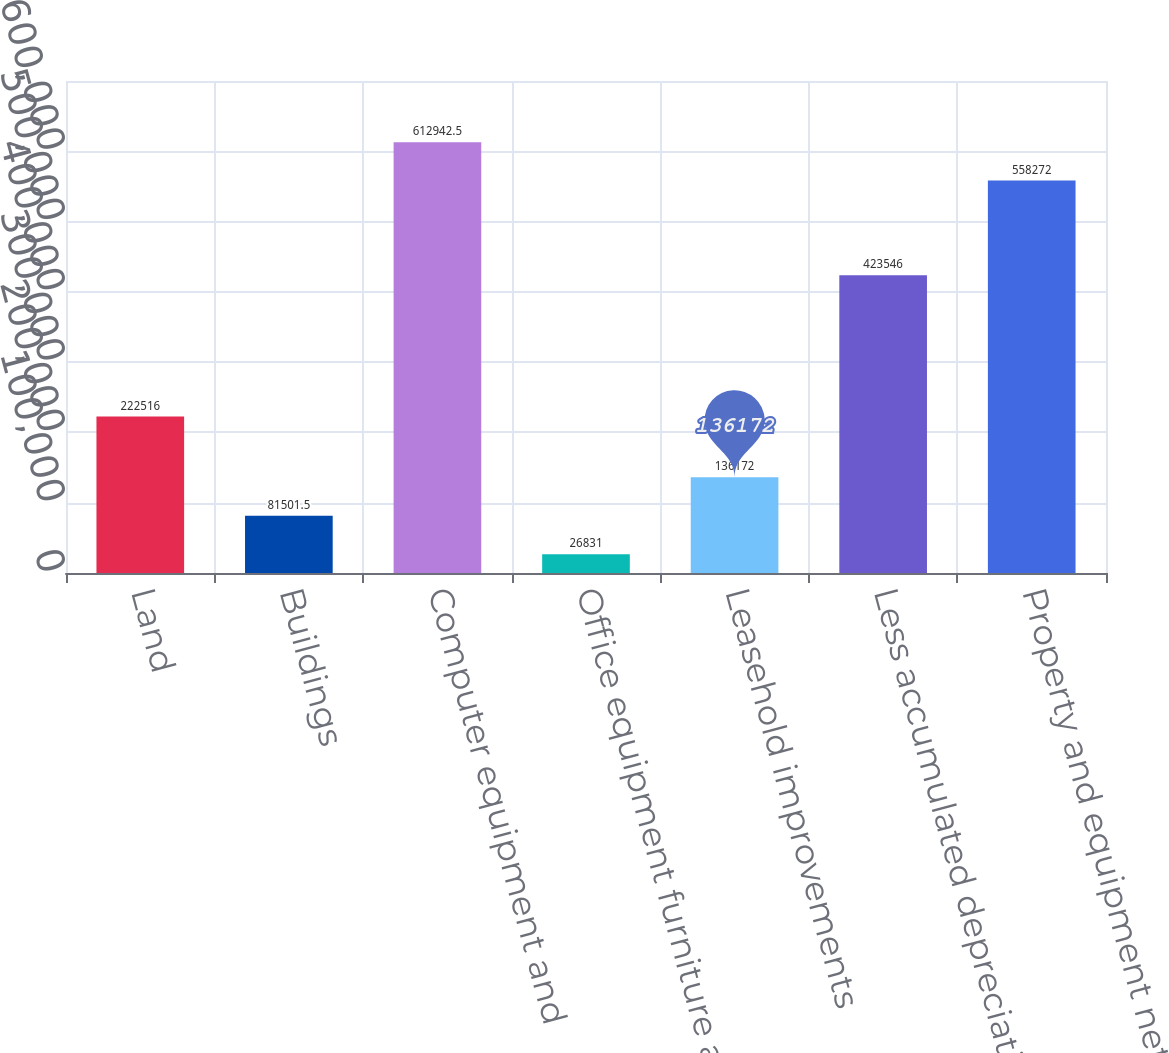Convert chart to OTSL. <chart><loc_0><loc_0><loc_500><loc_500><bar_chart><fcel>Land<fcel>Buildings<fcel>Computer equipment and<fcel>Office equipment furniture and<fcel>Leasehold improvements<fcel>Less accumulated depreciation<fcel>Property and equipment net<nl><fcel>222516<fcel>81501.5<fcel>612942<fcel>26831<fcel>136172<fcel>423546<fcel>558272<nl></chart> 